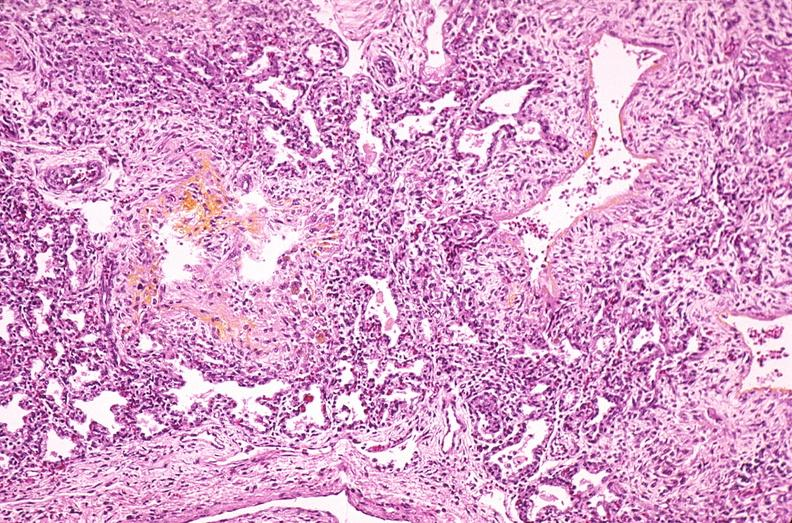what is present?
Answer the question using a single word or phrase. Respiratory 